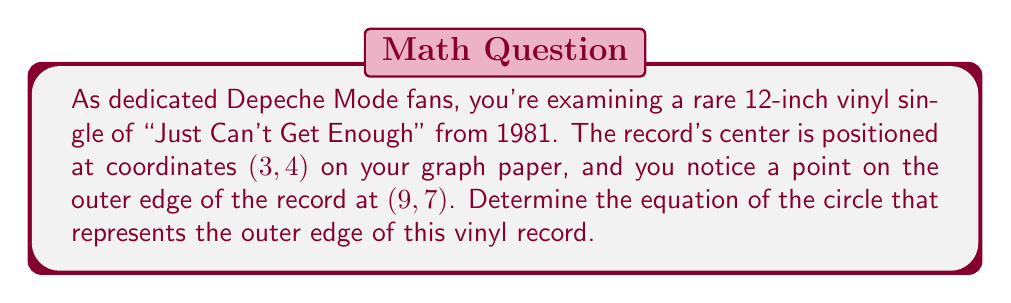Provide a solution to this math problem. Let's approach this step-by-step:

1) The general equation of a circle is:
   $$(x - h)^2 + (y - k)^2 = r^2$$
   where $(h, k)$ is the center and $r$ is the radius.

2) We're given that the center is at (3, 4), so $h = 3$ and $k = 4$.

3) To find the radius, we need to calculate the distance between the center (3, 4) and the point on the edge (9, 7).

4) We can use the distance formula:
   $$r = \sqrt{(x_2 - x_1)^2 + (y_2 - y_1)^2}$$
   $$r = \sqrt{(9 - 3)^2 + (7 - 4)^2}$$
   $$r = \sqrt{6^2 + 3^2}$$
   $$r = \sqrt{36 + 9}$$
   $$r = \sqrt{45} = 3\sqrt{5}$$

5) Now we have all the components to form our equation:
   $$(x - 3)^2 + (y - 4)^2 = (3\sqrt{5})^2$$

6) Simplify the right side:
   $$(x - 3)^2 + (y - 4)^2 = 45$$

This is the equation of the circle representing the outer edge of the vinyl record.
Answer: $$(x - 3)^2 + (y - 4)^2 = 45$$ 